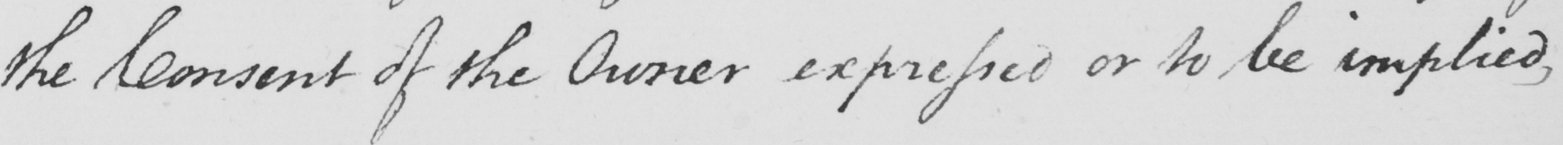Please transcribe the handwritten text in this image. the Consent of the Owner expressed or to be implied , 